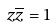Convert formula to latex. <formula><loc_0><loc_0><loc_500><loc_500>z \overline { z } = 1</formula> 